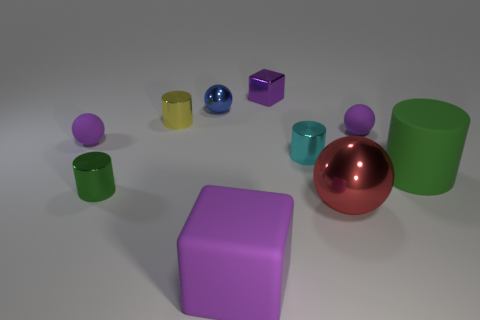The purple rubber object that is both behind the big rubber cube and to the left of the purple metal thing has what shape?
Your response must be concise. Sphere. What number of green cylinders are to the right of the rubber thing that is behind the tiny ball to the left of the tiny green thing?
Ensure brevity in your answer.  1. There is a green matte object that is the same shape as the cyan object; what is its size?
Your response must be concise. Large. Do the small sphere that is to the right of the purple matte block and the large purple thing have the same material?
Provide a short and direct response. Yes. What color is the rubber object that is the same shape as the cyan metal thing?
Provide a short and direct response. Green. How many other objects are the same color as the rubber block?
Provide a short and direct response. 3. There is a green object that is on the left side of the big green rubber cylinder; is it the same shape as the green thing behind the small green object?
Provide a succinct answer. Yes. What number of cubes are yellow objects or large yellow shiny objects?
Your answer should be compact. 0. Are there fewer large purple matte objects that are in front of the big red thing than large cyan rubber cylinders?
Offer a terse response. No. What number of other objects are the same material as the small purple cube?
Keep it short and to the point. 5. 